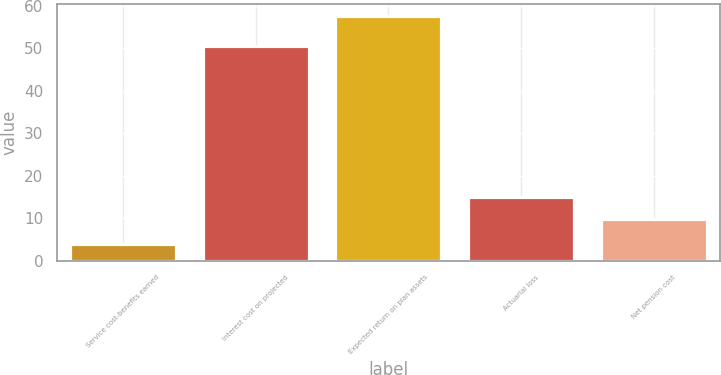Convert chart. <chart><loc_0><loc_0><loc_500><loc_500><bar_chart><fcel>Service cost-benefits earned<fcel>Interest cost on projected<fcel>Expected return on plan assets<fcel>Actuarial loss<fcel>Net pension cost<nl><fcel>4<fcel>50.6<fcel>57.5<fcel>15.05<fcel>9.7<nl></chart> 